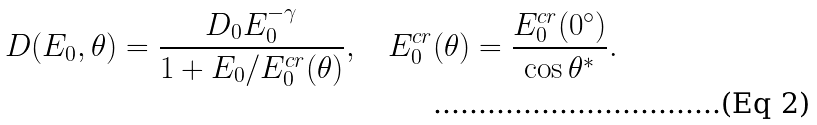Convert formula to latex. <formula><loc_0><loc_0><loc_500><loc_500>D ( E _ { 0 } , \theta ) = \frac { D _ { 0 } E _ { 0 } ^ { - \gamma } } { 1 + E _ { 0 } / E ^ { c r } _ { 0 } ( \theta ) } , \quad E ^ { c r } _ { 0 } ( \theta ) = \frac { E ^ { c r } _ { 0 } ( 0 ^ { \circ } ) } { \cos \theta ^ { * } } .</formula> 